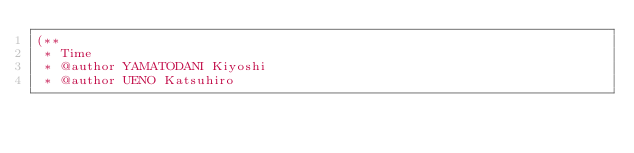Convert code to text. <code><loc_0><loc_0><loc_500><loc_500><_SML_>(**
 * Time
 * @author YAMATODANI Kiyoshi
 * @author UENO Katsuhiro</code> 